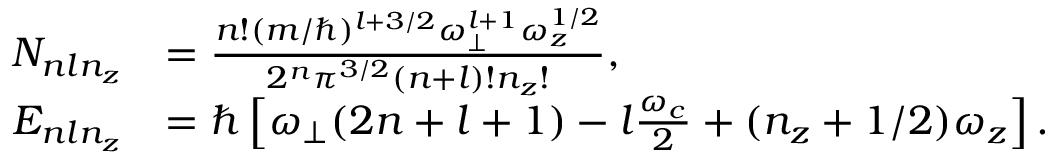Convert formula to latex. <formula><loc_0><loc_0><loc_500><loc_500>\begin{array} { r l } { N _ { n \ln _ { z } } } & { = \frac { n ! ( m / \hbar { ) } ^ { l + 3 / 2 } \omega _ { \perp } ^ { l + 1 } \omega _ { z } ^ { 1 / 2 } } { 2 ^ { n } \pi ^ { 3 / 2 } ( n + l ) ! n _ { z } ! } , } \\ { E _ { n \ln _ { z } } } & { = \hbar { \left } [ \omega _ { \perp } ( 2 n + l + 1 ) - l \frac { \omega _ { c } } { 2 } + ( n _ { z } + 1 / 2 ) \omega _ { z } \right ] . } \end{array}</formula> 